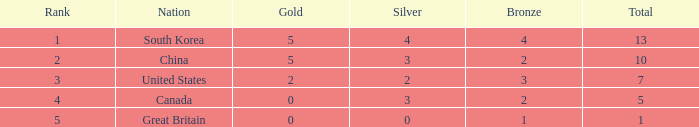What is the average Silver, when Rank is 5, and when Bronze is less than 1? None. 